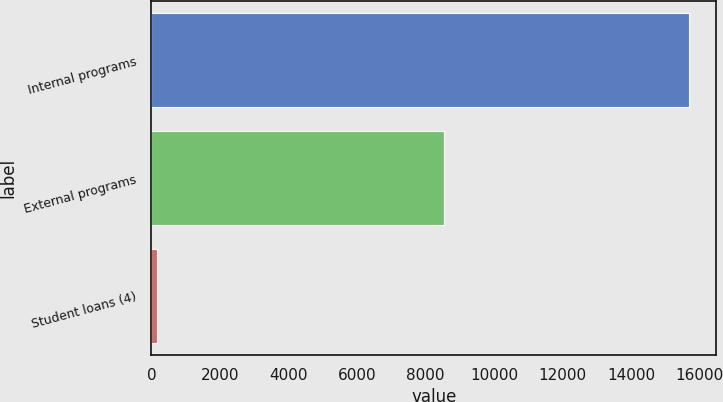Convert chart to OTSL. <chart><loc_0><loc_0><loc_500><loc_500><bar_chart><fcel>Internal programs<fcel>External programs<fcel>Student loans (4)<nl><fcel>15703<fcel>8543<fcel>172<nl></chart> 